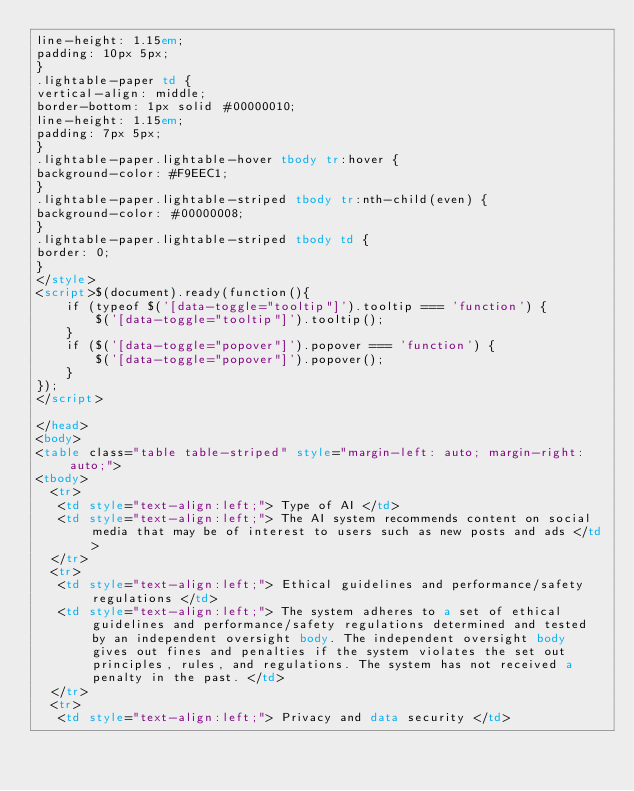<code> <loc_0><loc_0><loc_500><loc_500><_HTML_>line-height: 1.15em;
padding: 10px 5px;
}
.lightable-paper td {
vertical-align: middle;
border-bottom: 1px solid #00000010;
line-height: 1.15em;
padding: 7px 5px;
}
.lightable-paper.lightable-hover tbody tr:hover {
background-color: #F9EEC1;
}
.lightable-paper.lightable-striped tbody tr:nth-child(even) {
background-color: #00000008;
}
.lightable-paper.lightable-striped tbody td {
border: 0;
}
</style>
<script>$(document).ready(function(){
    if (typeof $('[data-toggle="tooltip"]').tooltip === 'function') {
        $('[data-toggle="tooltip"]').tooltip();
    }
    if ($('[data-toggle="popover"]').popover === 'function') {
        $('[data-toggle="popover"]').popover();
    }
});
</script>

</head>
<body>
<table class="table table-striped" style="margin-left: auto; margin-right: auto;">
<tbody>
  <tr>
   <td style="text-align:left;"> Type of AI </td>
   <td style="text-align:left;"> The AI system recommends content on social media that may be of interest to users such as new posts and ads </td>
  </tr>
  <tr>
   <td style="text-align:left;"> Ethical guidelines and performance/safety regulations </td>
   <td style="text-align:left;"> The system adheres to a set of ethical guidelines and performance/safety regulations determined and tested by an independent oversight body. The independent oversight body gives out fines and penalties if the system violates the set out principles, rules, and regulations. The system has not received a penalty in the past. </td>
  </tr>
  <tr>
   <td style="text-align:left;"> Privacy and data security </td></code> 